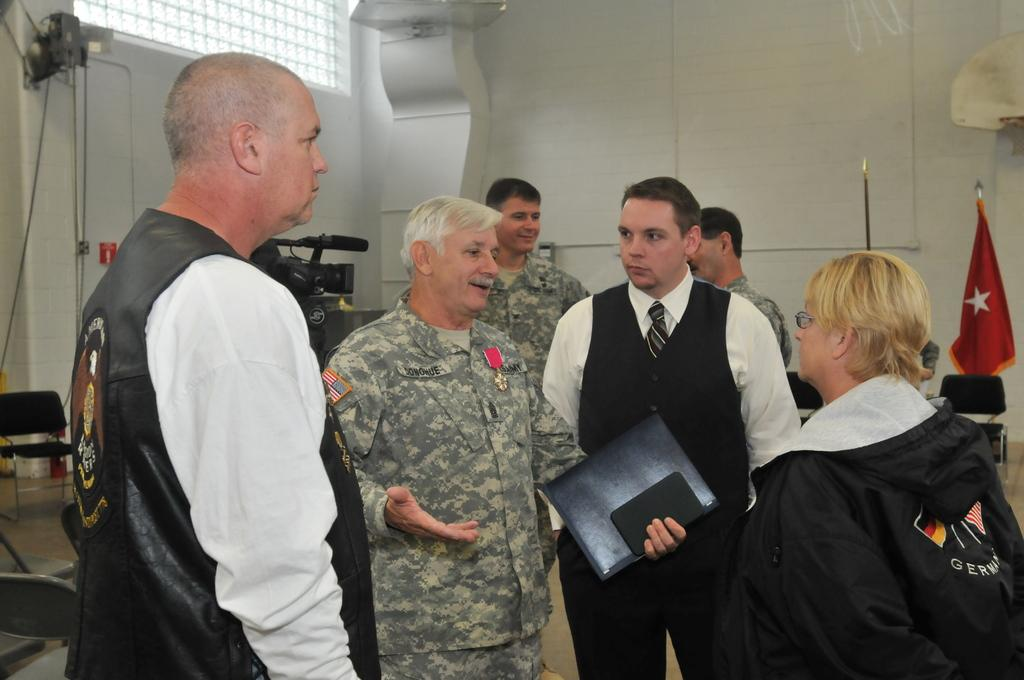What is located in the foreground of the image? There are people in the foreground of the image. What can be seen in the background of the image? Chairs, wires, a pillar, a window, a flag, and other objects are visible in the background of the image. Can you describe the objects in the background of the image? The chairs are likely for seating, the wires may be for electrical purposes, the pillar could be a structural support, the window provides a view of the outside, the flag represents a country or organization, and the other objects are unspecified. What type of apple is hanging from the edge of the window in the image? There is no apple present in the image, and the window does not have an edge that could support an apple. 